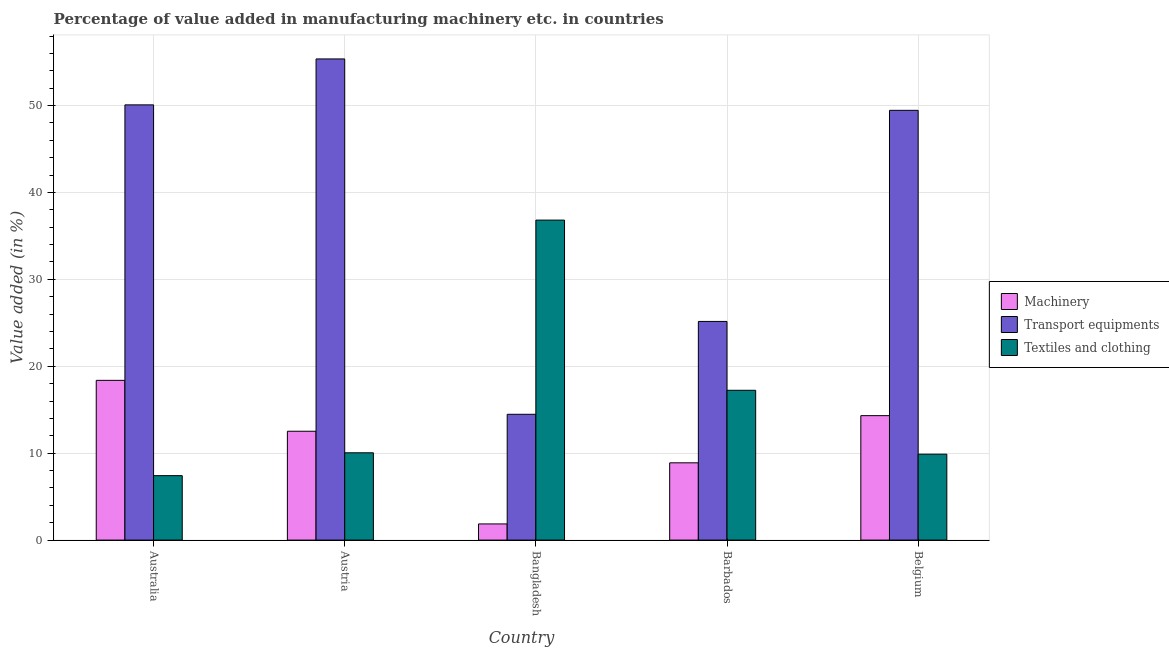How many groups of bars are there?
Your response must be concise. 5. How many bars are there on the 2nd tick from the left?
Provide a succinct answer. 3. What is the label of the 3rd group of bars from the left?
Provide a succinct answer. Bangladesh. What is the value added in manufacturing transport equipments in Bangladesh?
Make the answer very short. 14.48. Across all countries, what is the maximum value added in manufacturing machinery?
Provide a succinct answer. 18.38. Across all countries, what is the minimum value added in manufacturing transport equipments?
Keep it short and to the point. 14.48. What is the total value added in manufacturing textile and clothing in the graph?
Offer a terse response. 81.41. What is the difference between the value added in manufacturing textile and clothing in Australia and that in Barbados?
Your answer should be very brief. -9.82. What is the difference between the value added in manufacturing machinery in Bangladesh and the value added in manufacturing transport equipments in Barbados?
Ensure brevity in your answer.  -23.3. What is the average value added in manufacturing textile and clothing per country?
Offer a terse response. 16.28. What is the difference between the value added in manufacturing machinery and value added in manufacturing textile and clothing in Austria?
Your answer should be compact. 2.48. In how many countries, is the value added in manufacturing textile and clothing greater than 26 %?
Keep it short and to the point. 1. What is the ratio of the value added in manufacturing transport equipments in Barbados to that in Belgium?
Your answer should be very brief. 0.51. What is the difference between the highest and the second highest value added in manufacturing transport equipments?
Your response must be concise. 5.28. What is the difference between the highest and the lowest value added in manufacturing textile and clothing?
Keep it short and to the point. 29.4. In how many countries, is the value added in manufacturing machinery greater than the average value added in manufacturing machinery taken over all countries?
Provide a succinct answer. 3. What does the 3rd bar from the left in Barbados represents?
Offer a very short reply. Textiles and clothing. What does the 1st bar from the right in Bangladesh represents?
Provide a succinct answer. Textiles and clothing. How many bars are there?
Offer a very short reply. 15. How many legend labels are there?
Give a very brief answer. 3. What is the title of the graph?
Make the answer very short. Percentage of value added in manufacturing machinery etc. in countries. Does "Tertiary" appear as one of the legend labels in the graph?
Ensure brevity in your answer.  No. What is the label or title of the Y-axis?
Your answer should be compact. Value added (in %). What is the Value added (in %) of Machinery in Australia?
Your answer should be very brief. 18.38. What is the Value added (in %) of Transport equipments in Australia?
Ensure brevity in your answer.  50.08. What is the Value added (in %) of Textiles and clothing in Australia?
Offer a terse response. 7.42. What is the Value added (in %) in Machinery in Austria?
Provide a short and direct response. 12.53. What is the Value added (in %) of Transport equipments in Austria?
Provide a short and direct response. 55.36. What is the Value added (in %) in Textiles and clothing in Austria?
Your response must be concise. 10.05. What is the Value added (in %) in Machinery in Bangladesh?
Your answer should be compact. 1.86. What is the Value added (in %) of Transport equipments in Bangladesh?
Provide a succinct answer. 14.48. What is the Value added (in %) in Textiles and clothing in Bangladesh?
Your response must be concise. 36.82. What is the Value added (in %) in Machinery in Barbados?
Offer a terse response. 8.89. What is the Value added (in %) in Transport equipments in Barbados?
Provide a succinct answer. 25.16. What is the Value added (in %) of Textiles and clothing in Barbados?
Ensure brevity in your answer.  17.24. What is the Value added (in %) of Machinery in Belgium?
Provide a short and direct response. 14.32. What is the Value added (in %) of Transport equipments in Belgium?
Give a very brief answer. 49.45. What is the Value added (in %) in Textiles and clothing in Belgium?
Offer a very short reply. 9.89. Across all countries, what is the maximum Value added (in %) of Machinery?
Give a very brief answer. 18.38. Across all countries, what is the maximum Value added (in %) in Transport equipments?
Ensure brevity in your answer.  55.36. Across all countries, what is the maximum Value added (in %) of Textiles and clothing?
Your answer should be compact. 36.82. Across all countries, what is the minimum Value added (in %) in Machinery?
Your answer should be compact. 1.86. Across all countries, what is the minimum Value added (in %) in Transport equipments?
Your answer should be very brief. 14.48. Across all countries, what is the minimum Value added (in %) in Textiles and clothing?
Offer a terse response. 7.42. What is the total Value added (in %) of Machinery in the graph?
Offer a very short reply. 55.98. What is the total Value added (in %) of Transport equipments in the graph?
Ensure brevity in your answer.  194.53. What is the total Value added (in %) in Textiles and clothing in the graph?
Provide a succinct answer. 81.41. What is the difference between the Value added (in %) of Machinery in Australia and that in Austria?
Give a very brief answer. 5.86. What is the difference between the Value added (in %) in Transport equipments in Australia and that in Austria?
Provide a short and direct response. -5.28. What is the difference between the Value added (in %) in Textiles and clothing in Australia and that in Austria?
Keep it short and to the point. -2.63. What is the difference between the Value added (in %) of Machinery in Australia and that in Bangladesh?
Provide a short and direct response. 16.52. What is the difference between the Value added (in %) of Transport equipments in Australia and that in Bangladesh?
Your answer should be compact. 35.6. What is the difference between the Value added (in %) in Textiles and clothing in Australia and that in Bangladesh?
Your response must be concise. -29.4. What is the difference between the Value added (in %) of Machinery in Australia and that in Barbados?
Make the answer very short. 9.49. What is the difference between the Value added (in %) of Transport equipments in Australia and that in Barbados?
Provide a short and direct response. 24.92. What is the difference between the Value added (in %) of Textiles and clothing in Australia and that in Barbados?
Keep it short and to the point. -9.82. What is the difference between the Value added (in %) of Machinery in Australia and that in Belgium?
Offer a very short reply. 4.06. What is the difference between the Value added (in %) of Transport equipments in Australia and that in Belgium?
Make the answer very short. 0.63. What is the difference between the Value added (in %) of Textiles and clothing in Australia and that in Belgium?
Keep it short and to the point. -2.47. What is the difference between the Value added (in %) of Machinery in Austria and that in Bangladesh?
Your answer should be compact. 10.66. What is the difference between the Value added (in %) in Transport equipments in Austria and that in Bangladesh?
Offer a terse response. 40.89. What is the difference between the Value added (in %) in Textiles and clothing in Austria and that in Bangladesh?
Your answer should be compact. -26.77. What is the difference between the Value added (in %) of Machinery in Austria and that in Barbados?
Make the answer very short. 3.63. What is the difference between the Value added (in %) of Transport equipments in Austria and that in Barbados?
Make the answer very short. 30.2. What is the difference between the Value added (in %) in Textiles and clothing in Austria and that in Barbados?
Your response must be concise. -7.19. What is the difference between the Value added (in %) in Machinery in Austria and that in Belgium?
Provide a short and direct response. -1.79. What is the difference between the Value added (in %) in Transport equipments in Austria and that in Belgium?
Your answer should be very brief. 5.91. What is the difference between the Value added (in %) in Textiles and clothing in Austria and that in Belgium?
Provide a short and direct response. 0.16. What is the difference between the Value added (in %) in Machinery in Bangladesh and that in Barbados?
Provide a short and direct response. -7.03. What is the difference between the Value added (in %) of Transport equipments in Bangladesh and that in Barbados?
Your answer should be very brief. -10.68. What is the difference between the Value added (in %) in Textiles and clothing in Bangladesh and that in Barbados?
Make the answer very short. 19.58. What is the difference between the Value added (in %) in Machinery in Bangladesh and that in Belgium?
Provide a succinct answer. -12.46. What is the difference between the Value added (in %) of Transport equipments in Bangladesh and that in Belgium?
Give a very brief answer. -34.97. What is the difference between the Value added (in %) of Textiles and clothing in Bangladesh and that in Belgium?
Your answer should be very brief. 26.93. What is the difference between the Value added (in %) of Machinery in Barbados and that in Belgium?
Your response must be concise. -5.43. What is the difference between the Value added (in %) in Transport equipments in Barbados and that in Belgium?
Your answer should be compact. -24.29. What is the difference between the Value added (in %) in Textiles and clothing in Barbados and that in Belgium?
Your answer should be compact. 7.35. What is the difference between the Value added (in %) of Machinery in Australia and the Value added (in %) of Transport equipments in Austria?
Give a very brief answer. -36.98. What is the difference between the Value added (in %) of Machinery in Australia and the Value added (in %) of Textiles and clothing in Austria?
Give a very brief answer. 8.33. What is the difference between the Value added (in %) of Transport equipments in Australia and the Value added (in %) of Textiles and clothing in Austria?
Your answer should be compact. 40.03. What is the difference between the Value added (in %) of Machinery in Australia and the Value added (in %) of Transport equipments in Bangladesh?
Provide a succinct answer. 3.9. What is the difference between the Value added (in %) in Machinery in Australia and the Value added (in %) in Textiles and clothing in Bangladesh?
Ensure brevity in your answer.  -18.44. What is the difference between the Value added (in %) in Transport equipments in Australia and the Value added (in %) in Textiles and clothing in Bangladesh?
Your response must be concise. 13.26. What is the difference between the Value added (in %) in Machinery in Australia and the Value added (in %) in Transport equipments in Barbados?
Make the answer very short. -6.78. What is the difference between the Value added (in %) of Machinery in Australia and the Value added (in %) of Textiles and clothing in Barbados?
Your answer should be compact. 1.14. What is the difference between the Value added (in %) of Transport equipments in Australia and the Value added (in %) of Textiles and clothing in Barbados?
Give a very brief answer. 32.84. What is the difference between the Value added (in %) of Machinery in Australia and the Value added (in %) of Transport equipments in Belgium?
Offer a very short reply. -31.07. What is the difference between the Value added (in %) in Machinery in Australia and the Value added (in %) in Textiles and clothing in Belgium?
Give a very brief answer. 8.49. What is the difference between the Value added (in %) of Transport equipments in Australia and the Value added (in %) of Textiles and clothing in Belgium?
Keep it short and to the point. 40.19. What is the difference between the Value added (in %) of Machinery in Austria and the Value added (in %) of Transport equipments in Bangladesh?
Offer a very short reply. -1.95. What is the difference between the Value added (in %) in Machinery in Austria and the Value added (in %) in Textiles and clothing in Bangladesh?
Your answer should be compact. -24.29. What is the difference between the Value added (in %) of Transport equipments in Austria and the Value added (in %) of Textiles and clothing in Bangladesh?
Your answer should be very brief. 18.54. What is the difference between the Value added (in %) of Machinery in Austria and the Value added (in %) of Transport equipments in Barbados?
Ensure brevity in your answer.  -12.64. What is the difference between the Value added (in %) in Machinery in Austria and the Value added (in %) in Textiles and clothing in Barbados?
Provide a short and direct response. -4.71. What is the difference between the Value added (in %) in Transport equipments in Austria and the Value added (in %) in Textiles and clothing in Barbados?
Your answer should be very brief. 38.13. What is the difference between the Value added (in %) of Machinery in Austria and the Value added (in %) of Transport equipments in Belgium?
Offer a very short reply. -36.92. What is the difference between the Value added (in %) of Machinery in Austria and the Value added (in %) of Textiles and clothing in Belgium?
Offer a very short reply. 2.64. What is the difference between the Value added (in %) of Transport equipments in Austria and the Value added (in %) of Textiles and clothing in Belgium?
Keep it short and to the point. 45.48. What is the difference between the Value added (in %) of Machinery in Bangladesh and the Value added (in %) of Transport equipments in Barbados?
Ensure brevity in your answer.  -23.3. What is the difference between the Value added (in %) of Machinery in Bangladesh and the Value added (in %) of Textiles and clothing in Barbados?
Offer a terse response. -15.38. What is the difference between the Value added (in %) in Transport equipments in Bangladesh and the Value added (in %) in Textiles and clothing in Barbados?
Give a very brief answer. -2.76. What is the difference between the Value added (in %) of Machinery in Bangladesh and the Value added (in %) of Transport equipments in Belgium?
Your response must be concise. -47.59. What is the difference between the Value added (in %) of Machinery in Bangladesh and the Value added (in %) of Textiles and clothing in Belgium?
Your answer should be very brief. -8.03. What is the difference between the Value added (in %) in Transport equipments in Bangladesh and the Value added (in %) in Textiles and clothing in Belgium?
Offer a very short reply. 4.59. What is the difference between the Value added (in %) of Machinery in Barbados and the Value added (in %) of Transport equipments in Belgium?
Ensure brevity in your answer.  -40.56. What is the difference between the Value added (in %) of Machinery in Barbados and the Value added (in %) of Textiles and clothing in Belgium?
Offer a terse response. -1. What is the difference between the Value added (in %) in Transport equipments in Barbados and the Value added (in %) in Textiles and clothing in Belgium?
Provide a short and direct response. 15.27. What is the average Value added (in %) of Machinery per country?
Offer a very short reply. 11.2. What is the average Value added (in %) of Transport equipments per country?
Provide a succinct answer. 38.91. What is the average Value added (in %) in Textiles and clothing per country?
Make the answer very short. 16.28. What is the difference between the Value added (in %) in Machinery and Value added (in %) in Transport equipments in Australia?
Ensure brevity in your answer.  -31.7. What is the difference between the Value added (in %) of Machinery and Value added (in %) of Textiles and clothing in Australia?
Offer a very short reply. 10.96. What is the difference between the Value added (in %) in Transport equipments and Value added (in %) in Textiles and clothing in Australia?
Provide a short and direct response. 42.66. What is the difference between the Value added (in %) of Machinery and Value added (in %) of Transport equipments in Austria?
Offer a terse response. -42.84. What is the difference between the Value added (in %) in Machinery and Value added (in %) in Textiles and clothing in Austria?
Provide a short and direct response. 2.48. What is the difference between the Value added (in %) in Transport equipments and Value added (in %) in Textiles and clothing in Austria?
Give a very brief answer. 45.32. What is the difference between the Value added (in %) of Machinery and Value added (in %) of Transport equipments in Bangladesh?
Give a very brief answer. -12.62. What is the difference between the Value added (in %) in Machinery and Value added (in %) in Textiles and clothing in Bangladesh?
Keep it short and to the point. -34.96. What is the difference between the Value added (in %) of Transport equipments and Value added (in %) of Textiles and clothing in Bangladesh?
Make the answer very short. -22.34. What is the difference between the Value added (in %) in Machinery and Value added (in %) in Transport equipments in Barbados?
Your answer should be very brief. -16.27. What is the difference between the Value added (in %) in Machinery and Value added (in %) in Textiles and clothing in Barbados?
Your answer should be very brief. -8.35. What is the difference between the Value added (in %) of Transport equipments and Value added (in %) of Textiles and clothing in Barbados?
Offer a very short reply. 7.92. What is the difference between the Value added (in %) of Machinery and Value added (in %) of Transport equipments in Belgium?
Provide a short and direct response. -35.13. What is the difference between the Value added (in %) of Machinery and Value added (in %) of Textiles and clothing in Belgium?
Keep it short and to the point. 4.43. What is the difference between the Value added (in %) in Transport equipments and Value added (in %) in Textiles and clothing in Belgium?
Offer a terse response. 39.56. What is the ratio of the Value added (in %) of Machinery in Australia to that in Austria?
Offer a terse response. 1.47. What is the ratio of the Value added (in %) of Transport equipments in Australia to that in Austria?
Ensure brevity in your answer.  0.9. What is the ratio of the Value added (in %) of Textiles and clothing in Australia to that in Austria?
Ensure brevity in your answer.  0.74. What is the ratio of the Value added (in %) in Machinery in Australia to that in Bangladesh?
Offer a very short reply. 9.88. What is the ratio of the Value added (in %) of Transport equipments in Australia to that in Bangladesh?
Provide a succinct answer. 3.46. What is the ratio of the Value added (in %) of Textiles and clothing in Australia to that in Bangladesh?
Offer a terse response. 0.2. What is the ratio of the Value added (in %) in Machinery in Australia to that in Barbados?
Make the answer very short. 2.07. What is the ratio of the Value added (in %) of Transport equipments in Australia to that in Barbados?
Offer a terse response. 1.99. What is the ratio of the Value added (in %) of Textiles and clothing in Australia to that in Barbados?
Your response must be concise. 0.43. What is the ratio of the Value added (in %) of Machinery in Australia to that in Belgium?
Provide a succinct answer. 1.28. What is the ratio of the Value added (in %) of Transport equipments in Australia to that in Belgium?
Make the answer very short. 1.01. What is the ratio of the Value added (in %) in Textiles and clothing in Australia to that in Belgium?
Offer a very short reply. 0.75. What is the ratio of the Value added (in %) in Machinery in Austria to that in Bangladesh?
Make the answer very short. 6.73. What is the ratio of the Value added (in %) in Transport equipments in Austria to that in Bangladesh?
Your answer should be very brief. 3.82. What is the ratio of the Value added (in %) in Textiles and clothing in Austria to that in Bangladesh?
Provide a succinct answer. 0.27. What is the ratio of the Value added (in %) of Machinery in Austria to that in Barbados?
Offer a terse response. 1.41. What is the ratio of the Value added (in %) of Transport equipments in Austria to that in Barbados?
Keep it short and to the point. 2.2. What is the ratio of the Value added (in %) in Textiles and clothing in Austria to that in Barbados?
Keep it short and to the point. 0.58. What is the ratio of the Value added (in %) in Machinery in Austria to that in Belgium?
Give a very brief answer. 0.87. What is the ratio of the Value added (in %) of Transport equipments in Austria to that in Belgium?
Keep it short and to the point. 1.12. What is the ratio of the Value added (in %) in Textiles and clothing in Austria to that in Belgium?
Your answer should be compact. 1.02. What is the ratio of the Value added (in %) of Machinery in Bangladesh to that in Barbados?
Provide a short and direct response. 0.21. What is the ratio of the Value added (in %) of Transport equipments in Bangladesh to that in Barbados?
Your response must be concise. 0.58. What is the ratio of the Value added (in %) of Textiles and clothing in Bangladesh to that in Barbados?
Keep it short and to the point. 2.14. What is the ratio of the Value added (in %) in Machinery in Bangladesh to that in Belgium?
Offer a terse response. 0.13. What is the ratio of the Value added (in %) in Transport equipments in Bangladesh to that in Belgium?
Give a very brief answer. 0.29. What is the ratio of the Value added (in %) of Textiles and clothing in Bangladesh to that in Belgium?
Your response must be concise. 3.72. What is the ratio of the Value added (in %) in Machinery in Barbados to that in Belgium?
Keep it short and to the point. 0.62. What is the ratio of the Value added (in %) of Transport equipments in Barbados to that in Belgium?
Offer a very short reply. 0.51. What is the ratio of the Value added (in %) of Textiles and clothing in Barbados to that in Belgium?
Ensure brevity in your answer.  1.74. What is the difference between the highest and the second highest Value added (in %) of Machinery?
Provide a succinct answer. 4.06. What is the difference between the highest and the second highest Value added (in %) in Transport equipments?
Ensure brevity in your answer.  5.28. What is the difference between the highest and the second highest Value added (in %) of Textiles and clothing?
Offer a very short reply. 19.58. What is the difference between the highest and the lowest Value added (in %) in Machinery?
Keep it short and to the point. 16.52. What is the difference between the highest and the lowest Value added (in %) of Transport equipments?
Give a very brief answer. 40.89. What is the difference between the highest and the lowest Value added (in %) in Textiles and clothing?
Your answer should be very brief. 29.4. 